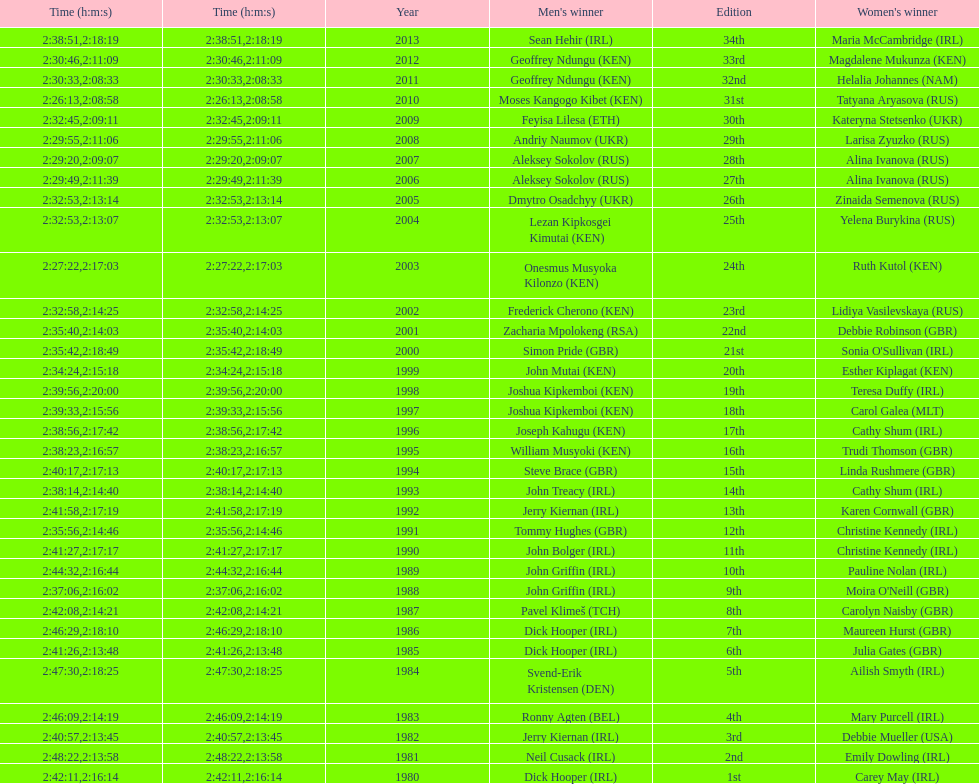Who won after joseph kipkemboi's winning streak ended? John Mutai (KEN). 